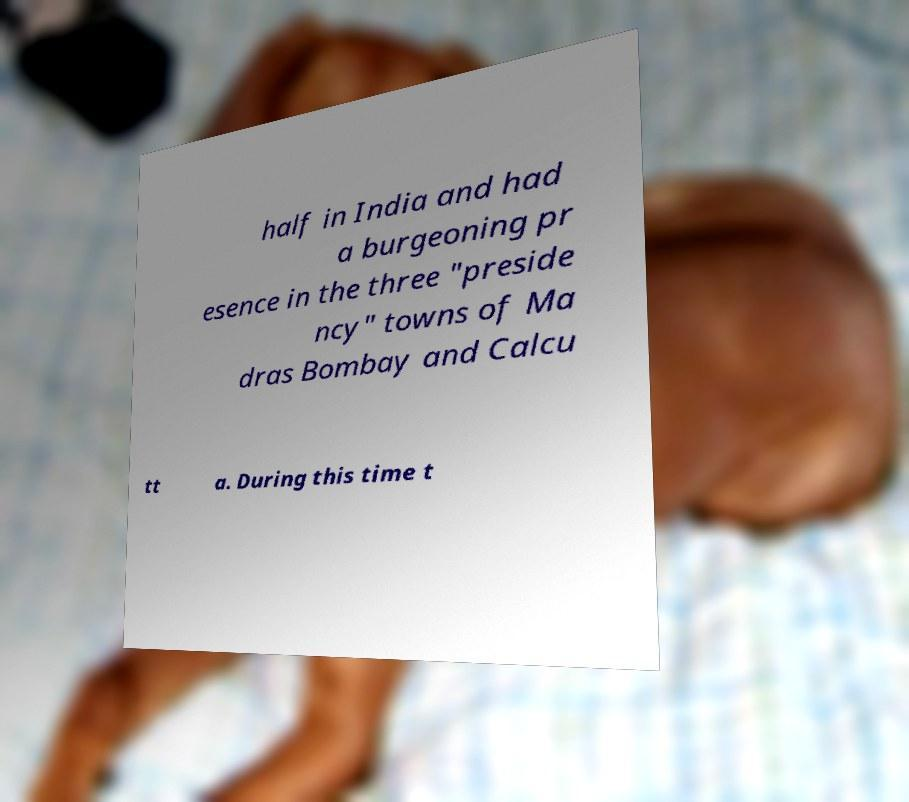Can you read and provide the text displayed in the image?This photo seems to have some interesting text. Can you extract and type it out for me? half in India and had a burgeoning pr esence in the three "preside ncy" towns of Ma dras Bombay and Calcu tt a. During this time t 